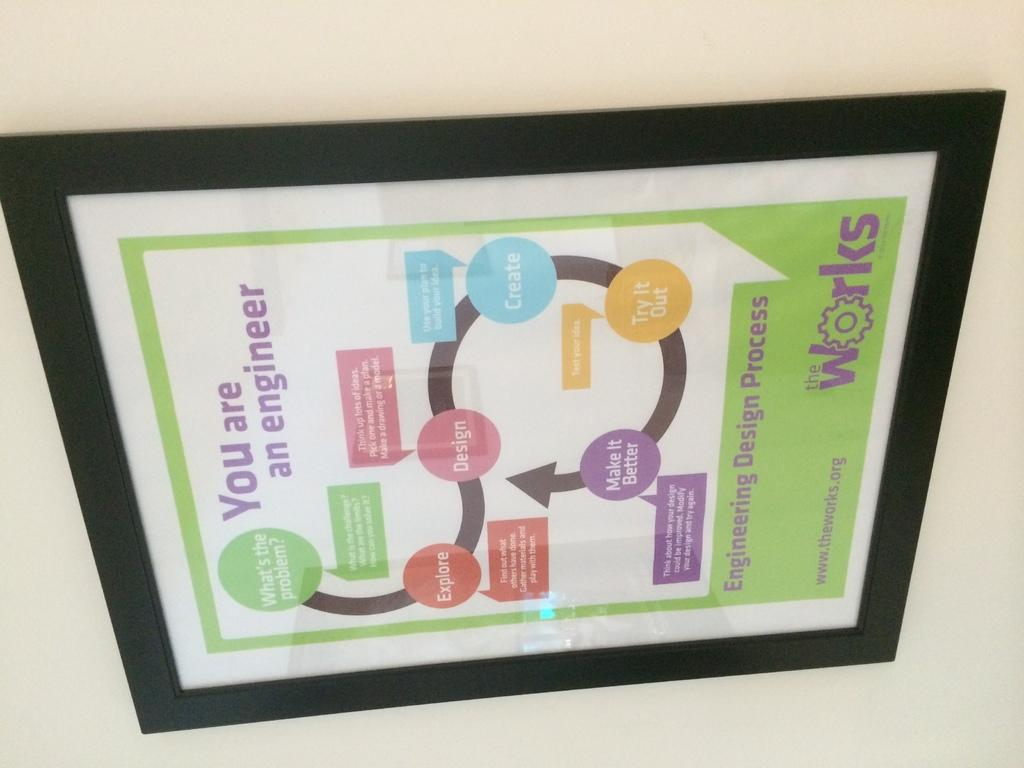Provide a one-sentence caption for the provided image. A framed diagram on a wall from theworks.org called You Are An Engineer. 